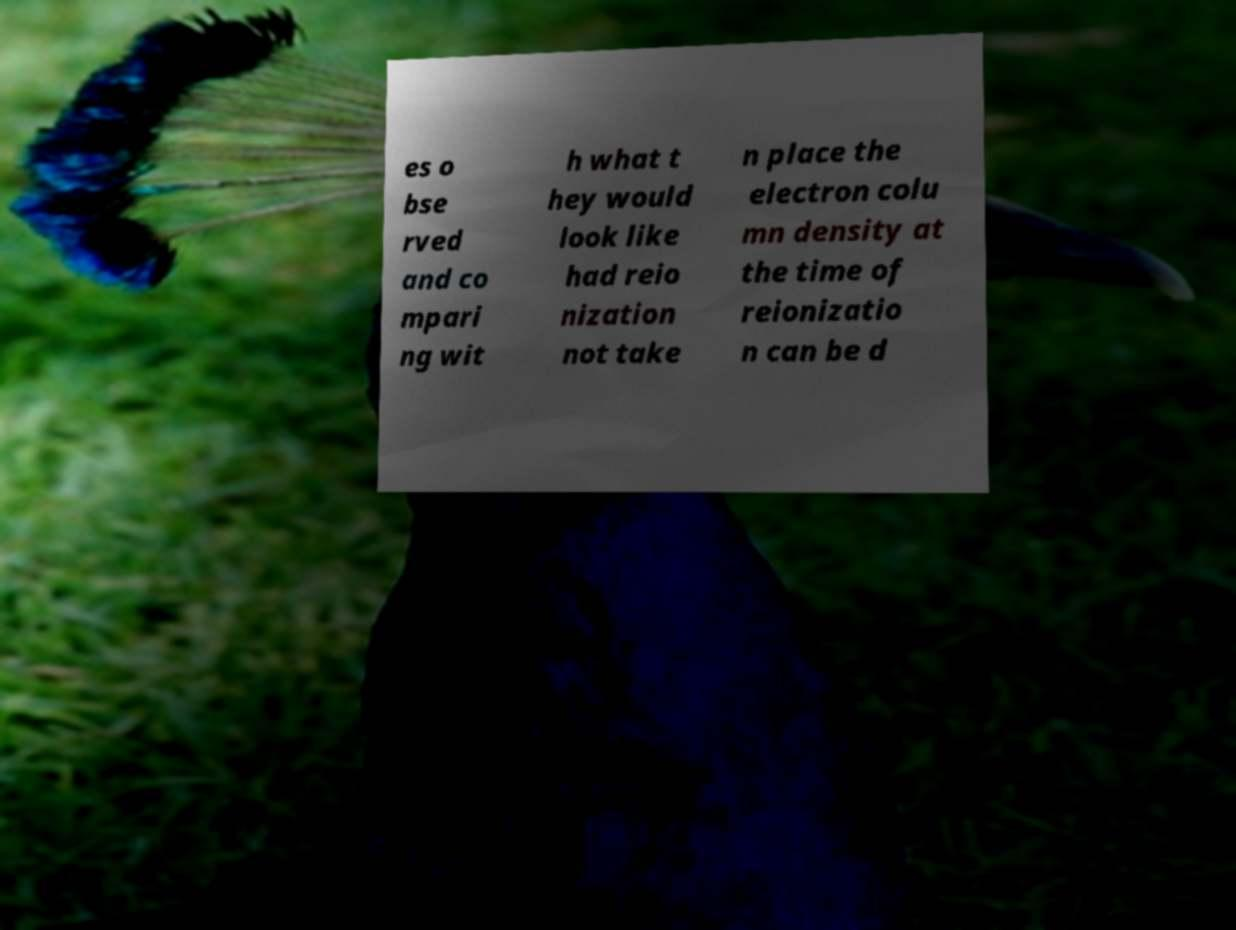Please identify and transcribe the text found in this image. es o bse rved and co mpari ng wit h what t hey would look like had reio nization not take n place the electron colu mn density at the time of reionizatio n can be d 